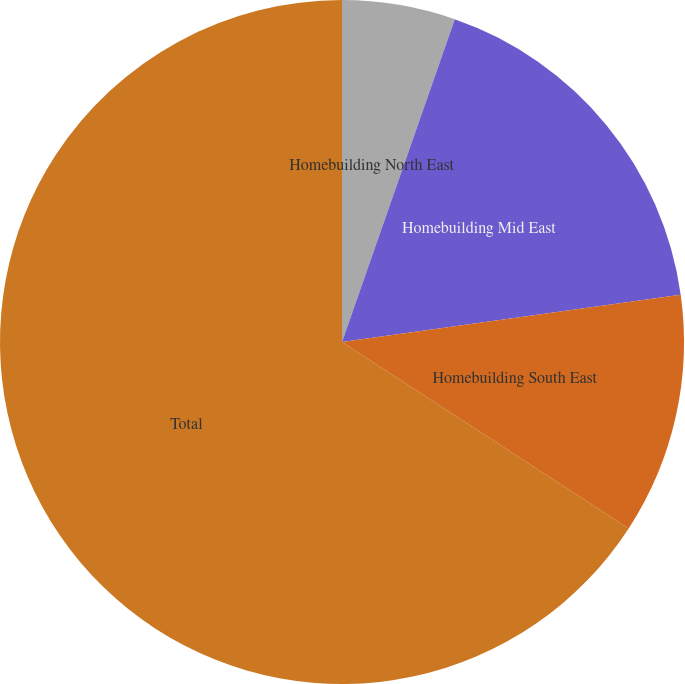<chart> <loc_0><loc_0><loc_500><loc_500><pie_chart><fcel>Homebuilding North East<fcel>Homebuilding Mid East<fcel>Homebuilding South East<fcel>Total<nl><fcel>5.35%<fcel>17.44%<fcel>11.39%<fcel>65.82%<nl></chart> 